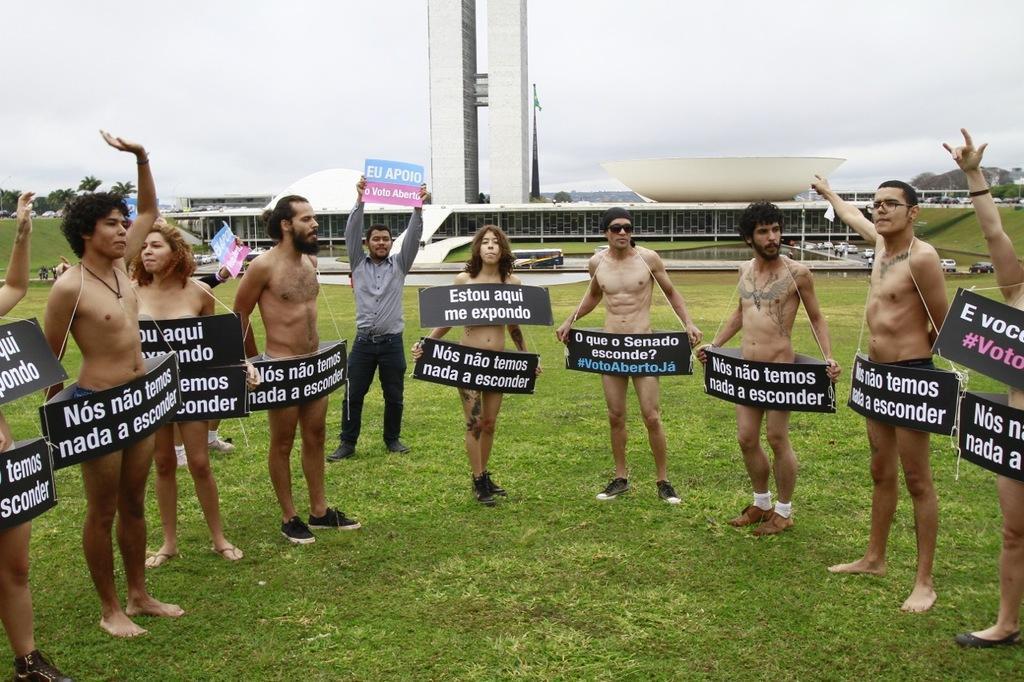In one or two sentences, can you explain what this image depicts? In this image there are few people standing wearing boards. Another person is standing here , he is holding a board. In the background there is a building. On the road many vehicles are moving. In the back there are trees and buildings. 